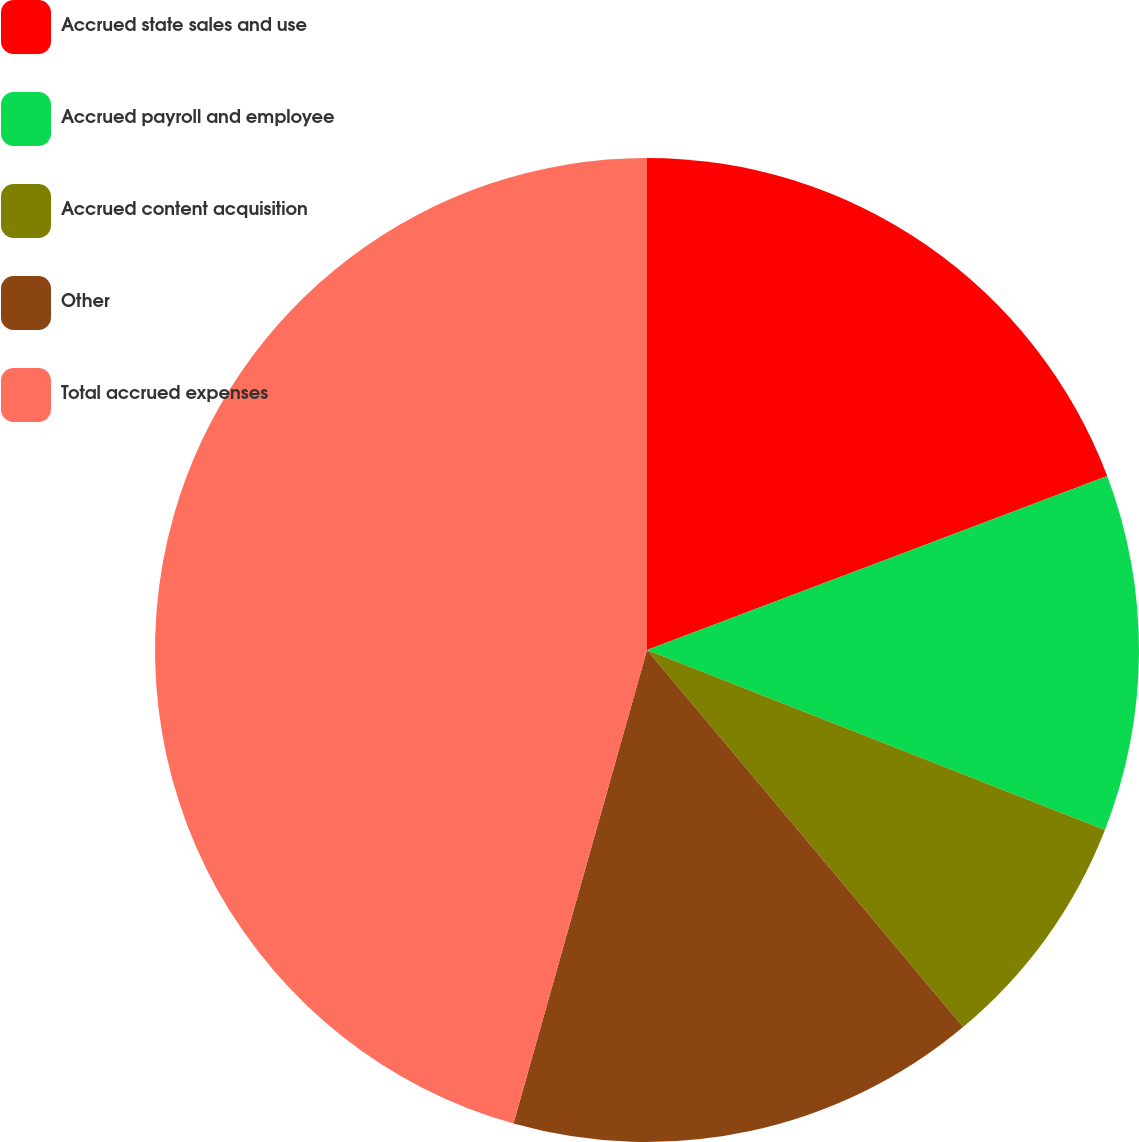<chart> <loc_0><loc_0><loc_500><loc_500><pie_chart><fcel>Accrued state sales and use<fcel>Accrued payroll and employee<fcel>Accrued content acquisition<fcel>Other<fcel>Total accrued expenses<nl><fcel>19.25%<fcel>11.71%<fcel>7.94%<fcel>15.48%<fcel>45.63%<nl></chart> 